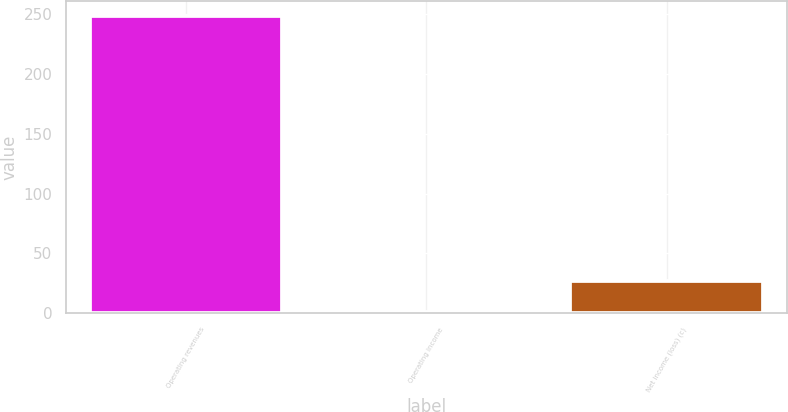Convert chart. <chart><loc_0><loc_0><loc_500><loc_500><bar_chart><fcel>Operating revenues<fcel>Operating income<fcel>Net income (loss) (c)<nl><fcel>248<fcel>1<fcel>27<nl></chart> 